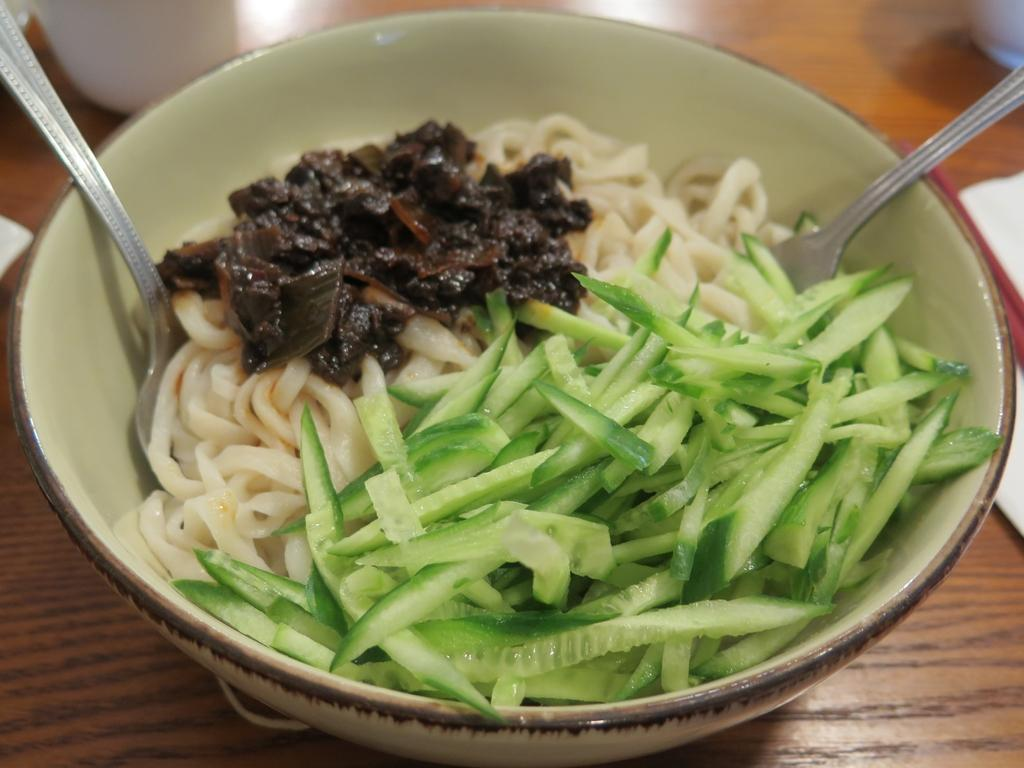What is on the table in the image? There is a bowl on the table. What is inside the bowl? There are food items in the bowl. What utensils are in the bowl? There are spoons in the bowl. What else can be seen on the table besides the bowl? There are objects on the table. What arithmetic problem is being solved by the cows in the image? There are no cows or arithmetic problems present in the image. What type of book is on the table in the image? There is no book present in the image. 